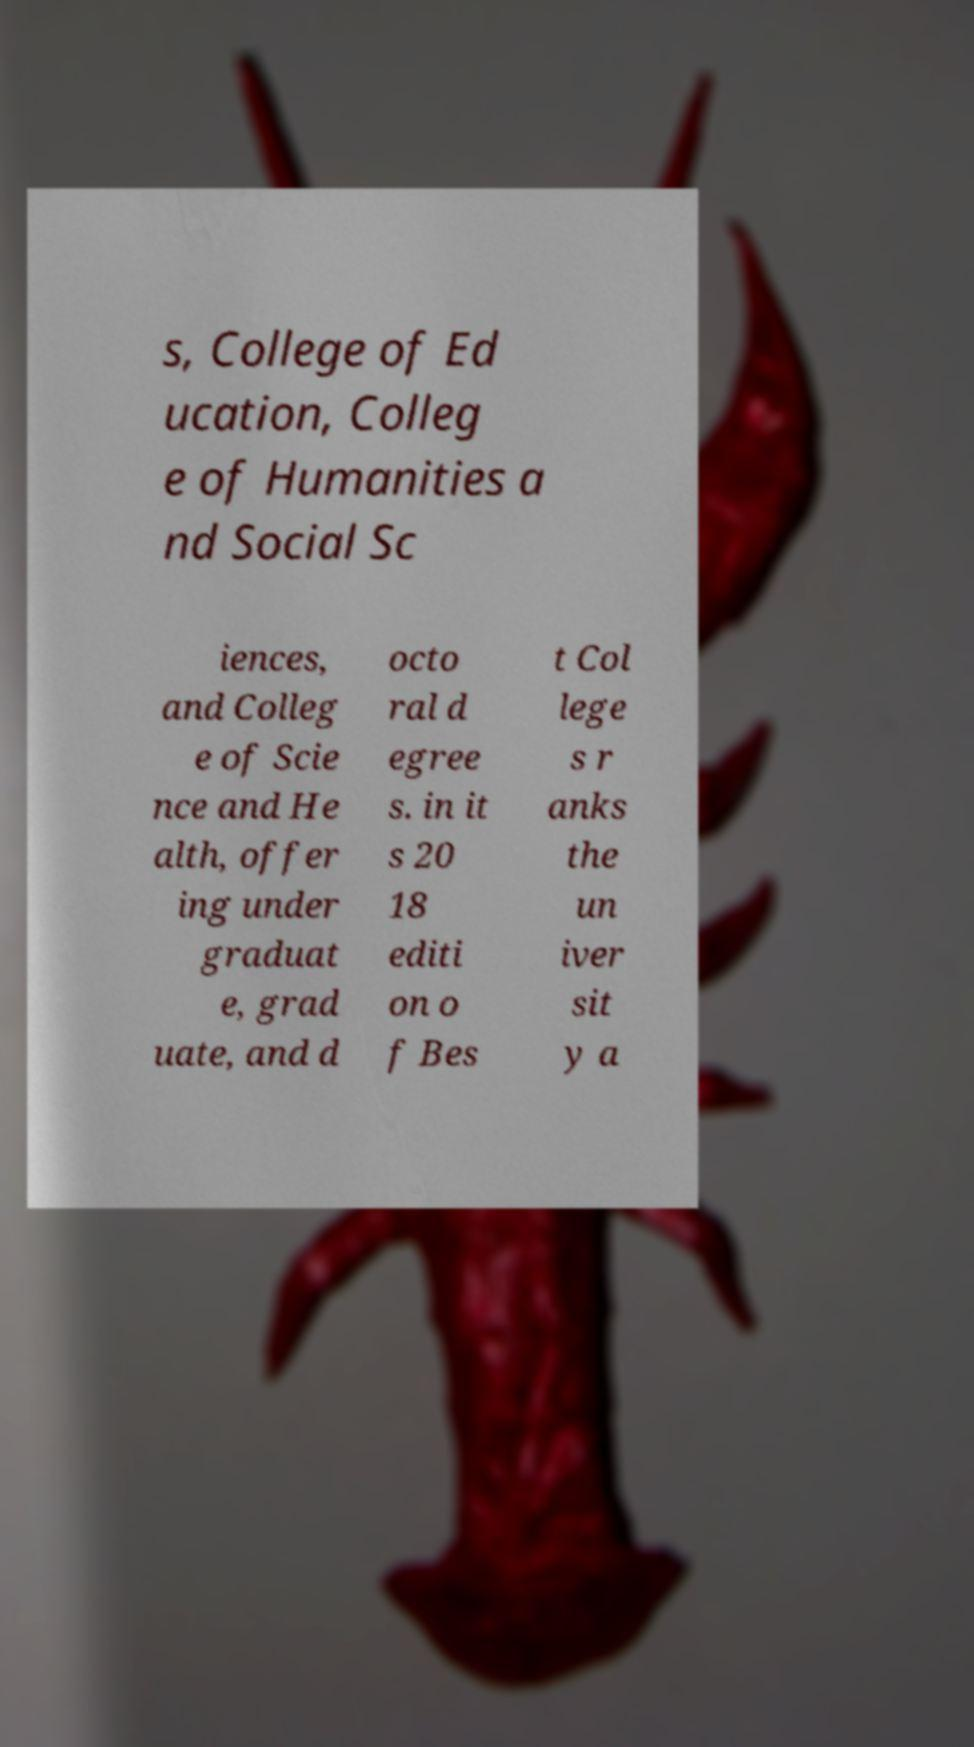I need the written content from this picture converted into text. Can you do that? s, College of Ed ucation, Colleg e of Humanities a nd Social Sc iences, and Colleg e of Scie nce and He alth, offer ing under graduat e, grad uate, and d octo ral d egree s. in it s 20 18 editi on o f Bes t Col lege s r anks the un iver sit y a 